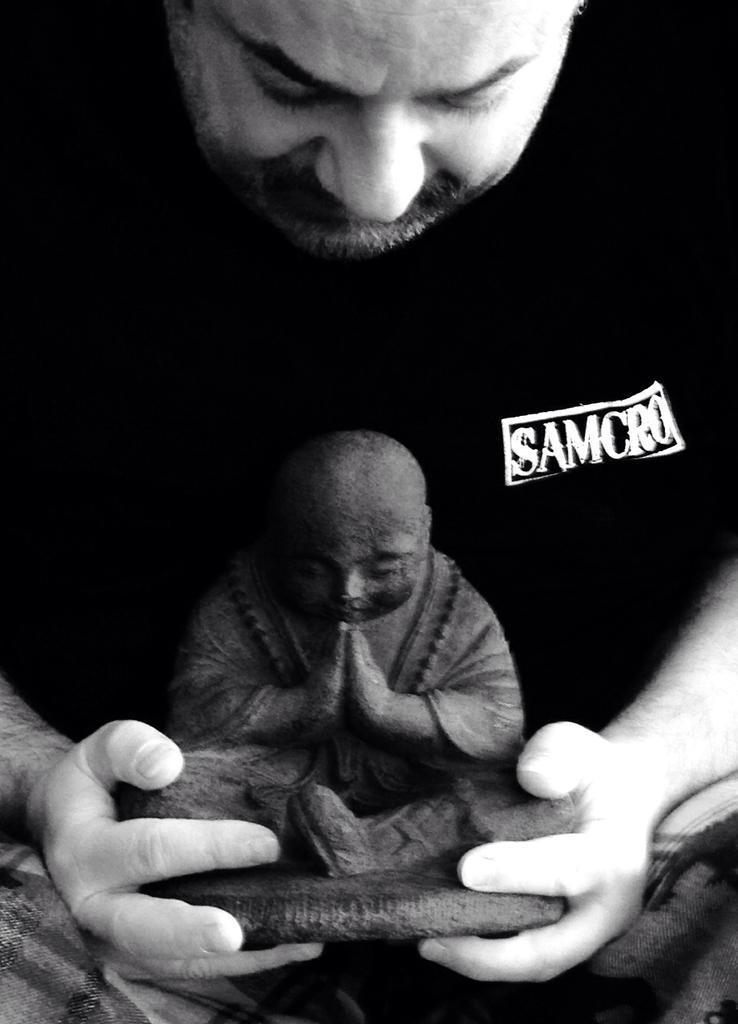Describe this image in one or two sentences. In this picture we can see a person holding a statue. 